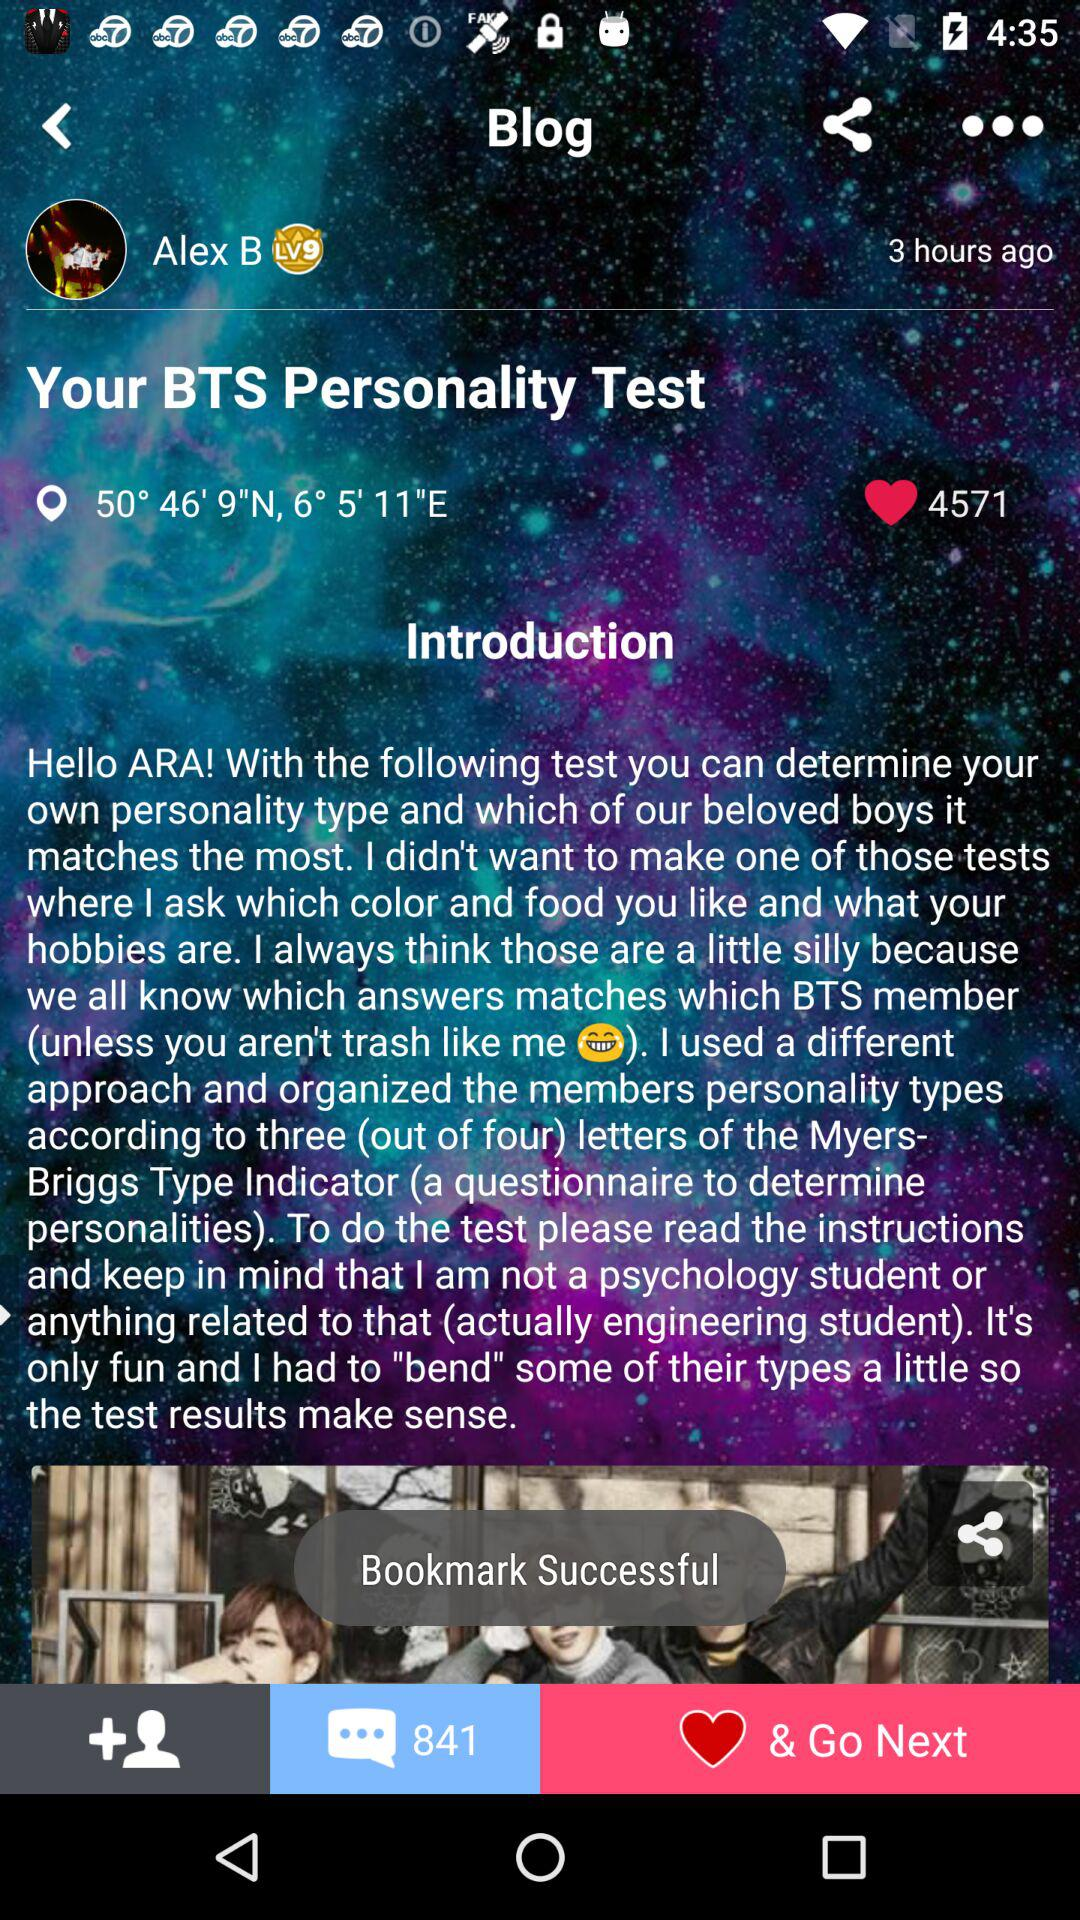How many hearts does the blog have?
Answer the question using a single word or phrase. 4571 